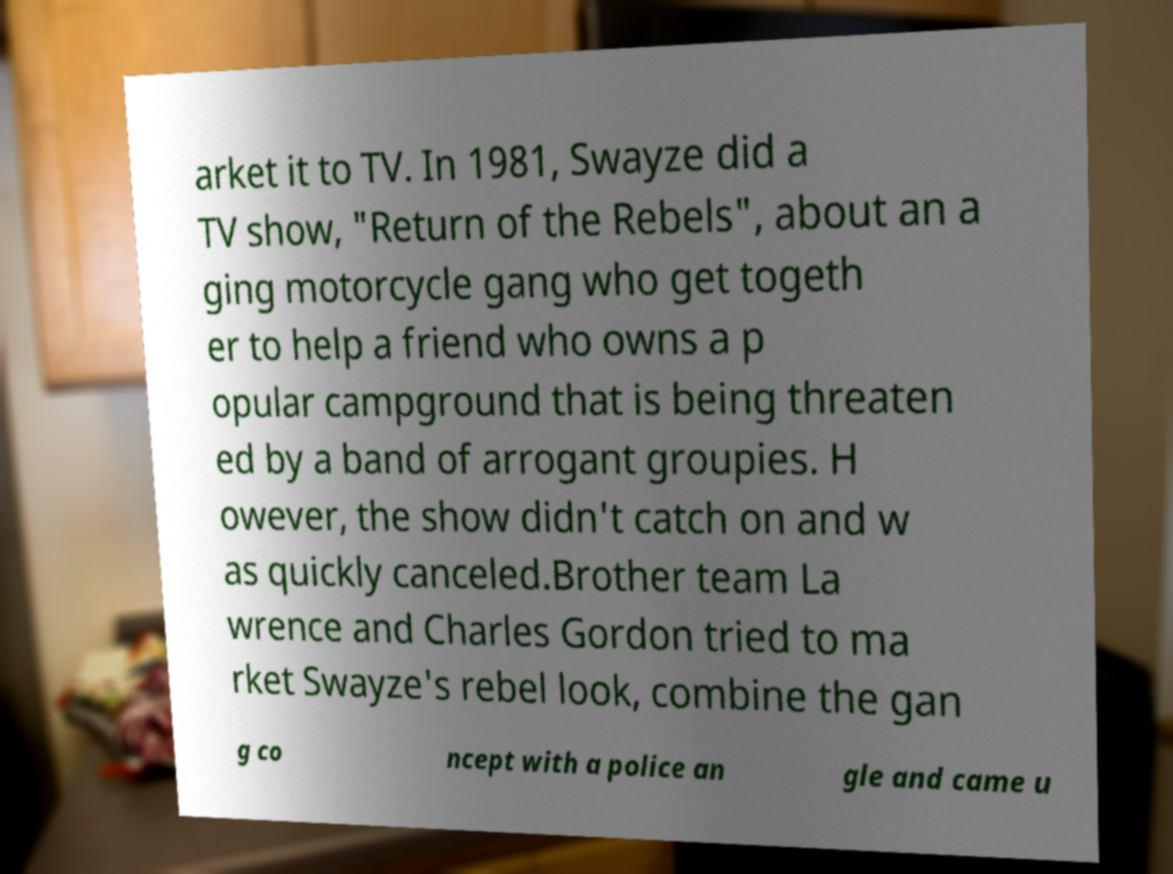Can you read and provide the text displayed in the image?This photo seems to have some interesting text. Can you extract and type it out for me? arket it to TV. In 1981, Swayze did a TV show, "Return of the Rebels", about an a ging motorcycle gang who get togeth er to help a friend who owns a p opular campground that is being threaten ed by a band of arrogant groupies. H owever, the show didn't catch on and w as quickly canceled.Brother team La wrence and Charles Gordon tried to ma rket Swayze's rebel look, combine the gan g co ncept with a police an gle and came u 